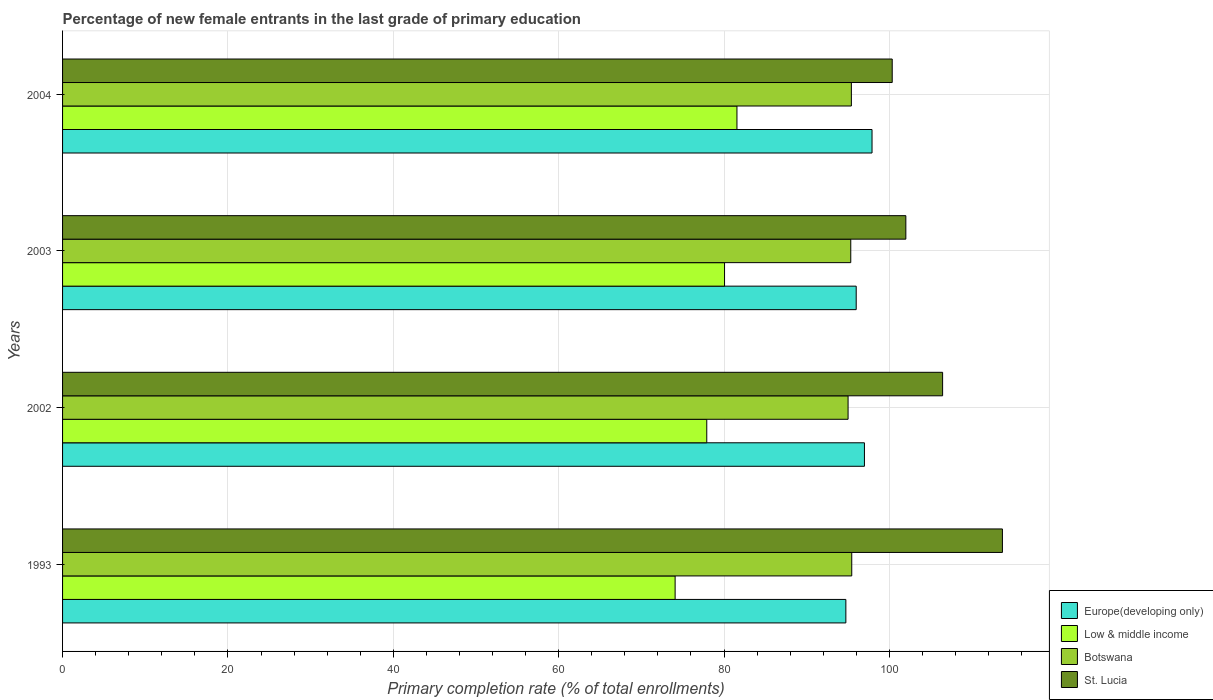Are the number of bars per tick equal to the number of legend labels?
Provide a short and direct response. Yes. Are the number of bars on each tick of the Y-axis equal?
Offer a very short reply. Yes. How many bars are there on the 4th tick from the top?
Keep it short and to the point. 4. What is the percentage of new female entrants in St. Lucia in 2004?
Your answer should be compact. 100.35. Across all years, what is the maximum percentage of new female entrants in St. Lucia?
Offer a terse response. 113.68. Across all years, what is the minimum percentage of new female entrants in St. Lucia?
Make the answer very short. 100.35. In which year was the percentage of new female entrants in Low & middle income maximum?
Provide a succinct answer. 2004. What is the total percentage of new female entrants in Europe(developing only) in the graph?
Keep it short and to the point. 385.62. What is the difference between the percentage of new female entrants in Europe(developing only) in 2002 and that in 2003?
Your response must be concise. 1. What is the difference between the percentage of new female entrants in Europe(developing only) in 1993 and the percentage of new female entrants in St. Lucia in 2002?
Provide a short and direct response. -11.7. What is the average percentage of new female entrants in Europe(developing only) per year?
Your response must be concise. 96.41. In the year 2002, what is the difference between the percentage of new female entrants in Botswana and percentage of new female entrants in St. Lucia?
Your answer should be very brief. -11.43. In how many years, is the percentage of new female entrants in St. Lucia greater than 100 %?
Your answer should be compact. 4. What is the ratio of the percentage of new female entrants in St. Lucia in 2002 to that in 2003?
Your answer should be very brief. 1.04. Is the percentage of new female entrants in Europe(developing only) in 1993 less than that in 2003?
Give a very brief answer. Yes. Is the difference between the percentage of new female entrants in Botswana in 1993 and 2002 greater than the difference between the percentage of new female entrants in St. Lucia in 1993 and 2002?
Your answer should be very brief. No. What is the difference between the highest and the second highest percentage of new female entrants in St. Lucia?
Your response must be concise. 7.24. What is the difference between the highest and the lowest percentage of new female entrants in St. Lucia?
Provide a succinct answer. 13.33. Is the sum of the percentage of new female entrants in St. Lucia in 2002 and 2003 greater than the maximum percentage of new female entrants in Low & middle income across all years?
Make the answer very short. Yes. What does the 4th bar from the top in 2002 represents?
Your answer should be very brief. Europe(developing only). Is it the case that in every year, the sum of the percentage of new female entrants in Low & middle income and percentage of new female entrants in St. Lucia is greater than the percentage of new female entrants in Botswana?
Keep it short and to the point. Yes. How many bars are there?
Offer a terse response. 16. Are all the bars in the graph horizontal?
Provide a short and direct response. Yes. Are the values on the major ticks of X-axis written in scientific E-notation?
Offer a terse response. No. Does the graph contain grids?
Ensure brevity in your answer.  Yes. How many legend labels are there?
Your response must be concise. 4. What is the title of the graph?
Provide a succinct answer. Percentage of new female entrants in the last grade of primary education. What is the label or title of the X-axis?
Offer a terse response. Primary completion rate (% of total enrollments). What is the label or title of the Y-axis?
Keep it short and to the point. Years. What is the Primary completion rate (% of total enrollments) in Europe(developing only) in 1993?
Offer a terse response. 94.74. What is the Primary completion rate (% of total enrollments) of Low & middle income in 1993?
Ensure brevity in your answer.  74.09. What is the Primary completion rate (% of total enrollments) of Botswana in 1993?
Ensure brevity in your answer.  95.45. What is the Primary completion rate (% of total enrollments) of St. Lucia in 1993?
Your response must be concise. 113.68. What is the Primary completion rate (% of total enrollments) of Europe(developing only) in 2002?
Your answer should be compact. 96.99. What is the Primary completion rate (% of total enrollments) in Low & middle income in 2002?
Make the answer very short. 77.92. What is the Primary completion rate (% of total enrollments) of Botswana in 2002?
Make the answer very short. 95.01. What is the Primary completion rate (% of total enrollments) of St. Lucia in 2002?
Offer a very short reply. 106.44. What is the Primary completion rate (% of total enrollments) in Europe(developing only) in 2003?
Ensure brevity in your answer.  95.99. What is the Primary completion rate (% of total enrollments) of Low & middle income in 2003?
Keep it short and to the point. 80.07. What is the Primary completion rate (% of total enrollments) in Botswana in 2003?
Provide a succinct answer. 95.33. What is the Primary completion rate (% of total enrollments) of St. Lucia in 2003?
Provide a short and direct response. 102. What is the Primary completion rate (% of total enrollments) of Europe(developing only) in 2004?
Give a very brief answer. 97.9. What is the Primary completion rate (% of total enrollments) in Low & middle income in 2004?
Ensure brevity in your answer.  81.57. What is the Primary completion rate (% of total enrollments) in Botswana in 2004?
Your response must be concise. 95.41. What is the Primary completion rate (% of total enrollments) of St. Lucia in 2004?
Provide a succinct answer. 100.35. Across all years, what is the maximum Primary completion rate (% of total enrollments) of Europe(developing only)?
Your answer should be very brief. 97.9. Across all years, what is the maximum Primary completion rate (% of total enrollments) in Low & middle income?
Ensure brevity in your answer.  81.57. Across all years, what is the maximum Primary completion rate (% of total enrollments) of Botswana?
Your answer should be compact. 95.45. Across all years, what is the maximum Primary completion rate (% of total enrollments) in St. Lucia?
Your answer should be compact. 113.68. Across all years, what is the minimum Primary completion rate (% of total enrollments) in Europe(developing only)?
Ensure brevity in your answer.  94.74. Across all years, what is the minimum Primary completion rate (% of total enrollments) in Low & middle income?
Provide a short and direct response. 74.09. Across all years, what is the minimum Primary completion rate (% of total enrollments) of Botswana?
Keep it short and to the point. 95.01. Across all years, what is the minimum Primary completion rate (% of total enrollments) in St. Lucia?
Your answer should be very brief. 100.35. What is the total Primary completion rate (% of total enrollments) in Europe(developing only) in the graph?
Make the answer very short. 385.62. What is the total Primary completion rate (% of total enrollments) in Low & middle income in the graph?
Provide a short and direct response. 313.64. What is the total Primary completion rate (% of total enrollments) in Botswana in the graph?
Keep it short and to the point. 381.2. What is the total Primary completion rate (% of total enrollments) in St. Lucia in the graph?
Provide a succinct answer. 422.46. What is the difference between the Primary completion rate (% of total enrollments) of Europe(developing only) in 1993 and that in 2002?
Your answer should be very brief. -2.25. What is the difference between the Primary completion rate (% of total enrollments) of Low & middle income in 1993 and that in 2002?
Ensure brevity in your answer.  -3.83. What is the difference between the Primary completion rate (% of total enrollments) in Botswana in 1993 and that in 2002?
Your response must be concise. 0.44. What is the difference between the Primary completion rate (% of total enrollments) of St. Lucia in 1993 and that in 2002?
Provide a succinct answer. 7.24. What is the difference between the Primary completion rate (% of total enrollments) in Europe(developing only) in 1993 and that in 2003?
Offer a very short reply. -1.25. What is the difference between the Primary completion rate (% of total enrollments) of Low & middle income in 1993 and that in 2003?
Provide a short and direct response. -5.98. What is the difference between the Primary completion rate (% of total enrollments) in Botswana in 1993 and that in 2003?
Provide a short and direct response. 0.12. What is the difference between the Primary completion rate (% of total enrollments) in St. Lucia in 1993 and that in 2003?
Make the answer very short. 11.68. What is the difference between the Primary completion rate (% of total enrollments) of Europe(developing only) in 1993 and that in 2004?
Your answer should be very brief. -3.17. What is the difference between the Primary completion rate (% of total enrollments) in Low & middle income in 1993 and that in 2004?
Provide a short and direct response. -7.48. What is the difference between the Primary completion rate (% of total enrollments) of Botswana in 1993 and that in 2004?
Give a very brief answer. 0.05. What is the difference between the Primary completion rate (% of total enrollments) in St. Lucia in 1993 and that in 2004?
Offer a terse response. 13.33. What is the difference between the Primary completion rate (% of total enrollments) of Europe(developing only) in 2002 and that in 2003?
Make the answer very short. 1. What is the difference between the Primary completion rate (% of total enrollments) of Low & middle income in 2002 and that in 2003?
Your response must be concise. -2.15. What is the difference between the Primary completion rate (% of total enrollments) of Botswana in 2002 and that in 2003?
Your response must be concise. -0.33. What is the difference between the Primary completion rate (% of total enrollments) in St. Lucia in 2002 and that in 2003?
Make the answer very short. 4.45. What is the difference between the Primary completion rate (% of total enrollments) in Europe(developing only) in 2002 and that in 2004?
Make the answer very short. -0.92. What is the difference between the Primary completion rate (% of total enrollments) of Low & middle income in 2002 and that in 2004?
Your response must be concise. -3.65. What is the difference between the Primary completion rate (% of total enrollments) in Botswana in 2002 and that in 2004?
Provide a succinct answer. -0.4. What is the difference between the Primary completion rate (% of total enrollments) in St. Lucia in 2002 and that in 2004?
Provide a short and direct response. 6.09. What is the difference between the Primary completion rate (% of total enrollments) of Europe(developing only) in 2003 and that in 2004?
Your response must be concise. -1.91. What is the difference between the Primary completion rate (% of total enrollments) in Low & middle income in 2003 and that in 2004?
Offer a very short reply. -1.5. What is the difference between the Primary completion rate (% of total enrollments) of Botswana in 2003 and that in 2004?
Provide a succinct answer. -0.07. What is the difference between the Primary completion rate (% of total enrollments) of St. Lucia in 2003 and that in 2004?
Provide a short and direct response. 1.65. What is the difference between the Primary completion rate (% of total enrollments) of Europe(developing only) in 1993 and the Primary completion rate (% of total enrollments) of Low & middle income in 2002?
Keep it short and to the point. 16.82. What is the difference between the Primary completion rate (% of total enrollments) of Europe(developing only) in 1993 and the Primary completion rate (% of total enrollments) of Botswana in 2002?
Your answer should be very brief. -0.27. What is the difference between the Primary completion rate (% of total enrollments) of Europe(developing only) in 1993 and the Primary completion rate (% of total enrollments) of St. Lucia in 2002?
Give a very brief answer. -11.7. What is the difference between the Primary completion rate (% of total enrollments) in Low & middle income in 1993 and the Primary completion rate (% of total enrollments) in Botswana in 2002?
Your answer should be very brief. -20.92. What is the difference between the Primary completion rate (% of total enrollments) of Low & middle income in 1993 and the Primary completion rate (% of total enrollments) of St. Lucia in 2002?
Offer a very short reply. -32.35. What is the difference between the Primary completion rate (% of total enrollments) in Botswana in 1993 and the Primary completion rate (% of total enrollments) in St. Lucia in 2002?
Give a very brief answer. -10.99. What is the difference between the Primary completion rate (% of total enrollments) in Europe(developing only) in 1993 and the Primary completion rate (% of total enrollments) in Low & middle income in 2003?
Provide a short and direct response. 14.67. What is the difference between the Primary completion rate (% of total enrollments) in Europe(developing only) in 1993 and the Primary completion rate (% of total enrollments) in Botswana in 2003?
Ensure brevity in your answer.  -0.59. What is the difference between the Primary completion rate (% of total enrollments) in Europe(developing only) in 1993 and the Primary completion rate (% of total enrollments) in St. Lucia in 2003?
Ensure brevity in your answer.  -7.26. What is the difference between the Primary completion rate (% of total enrollments) in Low & middle income in 1993 and the Primary completion rate (% of total enrollments) in Botswana in 2003?
Make the answer very short. -21.24. What is the difference between the Primary completion rate (% of total enrollments) in Low & middle income in 1993 and the Primary completion rate (% of total enrollments) in St. Lucia in 2003?
Provide a short and direct response. -27.91. What is the difference between the Primary completion rate (% of total enrollments) of Botswana in 1993 and the Primary completion rate (% of total enrollments) of St. Lucia in 2003?
Your answer should be compact. -6.54. What is the difference between the Primary completion rate (% of total enrollments) of Europe(developing only) in 1993 and the Primary completion rate (% of total enrollments) of Low & middle income in 2004?
Offer a very short reply. 13.17. What is the difference between the Primary completion rate (% of total enrollments) in Europe(developing only) in 1993 and the Primary completion rate (% of total enrollments) in Botswana in 2004?
Give a very brief answer. -0.67. What is the difference between the Primary completion rate (% of total enrollments) of Europe(developing only) in 1993 and the Primary completion rate (% of total enrollments) of St. Lucia in 2004?
Offer a very short reply. -5.61. What is the difference between the Primary completion rate (% of total enrollments) in Low & middle income in 1993 and the Primary completion rate (% of total enrollments) in Botswana in 2004?
Provide a short and direct response. -21.32. What is the difference between the Primary completion rate (% of total enrollments) of Low & middle income in 1993 and the Primary completion rate (% of total enrollments) of St. Lucia in 2004?
Offer a terse response. -26.26. What is the difference between the Primary completion rate (% of total enrollments) in Botswana in 1993 and the Primary completion rate (% of total enrollments) in St. Lucia in 2004?
Provide a short and direct response. -4.89. What is the difference between the Primary completion rate (% of total enrollments) of Europe(developing only) in 2002 and the Primary completion rate (% of total enrollments) of Low & middle income in 2003?
Offer a very short reply. 16.92. What is the difference between the Primary completion rate (% of total enrollments) in Europe(developing only) in 2002 and the Primary completion rate (% of total enrollments) in Botswana in 2003?
Your answer should be very brief. 1.65. What is the difference between the Primary completion rate (% of total enrollments) in Europe(developing only) in 2002 and the Primary completion rate (% of total enrollments) in St. Lucia in 2003?
Provide a succinct answer. -5.01. What is the difference between the Primary completion rate (% of total enrollments) of Low & middle income in 2002 and the Primary completion rate (% of total enrollments) of Botswana in 2003?
Provide a succinct answer. -17.42. What is the difference between the Primary completion rate (% of total enrollments) in Low & middle income in 2002 and the Primary completion rate (% of total enrollments) in St. Lucia in 2003?
Provide a short and direct response. -24.08. What is the difference between the Primary completion rate (% of total enrollments) in Botswana in 2002 and the Primary completion rate (% of total enrollments) in St. Lucia in 2003?
Your answer should be very brief. -6.99. What is the difference between the Primary completion rate (% of total enrollments) in Europe(developing only) in 2002 and the Primary completion rate (% of total enrollments) in Low & middle income in 2004?
Make the answer very short. 15.42. What is the difference between the Primary completion rate (% of total enrollments) of Europe(developing only) in 2002 and the Primary completion rate (% of total enrollments) of Botswana in 2004?
Offer a very short reply. 1.58. What is the difference between the Primary completion rate (% of total enrollments) in Europe(developing only) in 2002 and the Primary completion rate (% of total enrollments) in St. Lucia in 2004?
Offer a very short reply. -3.36. What is the difference between the Primary completion rate (% of total enrollments) in Low & middle income in 2002 and the Primary completion rate (% of total enrollments) in Botswana in 2004?
Give a very brief answer. -17.49. What is the difference between the Primary completion rate (% of total enrollments) in Low & middle income in 2002 and the Primary completion rate (% of total enrollments) in St. Lucia in 2004?
Your answer should be very brief. -22.43. What is the difference between the Primary completion rate (% of total enrollments) in Botswana in 2002 and the Primary completion rate (% of total enrollments) in St. Lucia in 2004?
Your answer should be very brief. -5.34. What is the difference between the Primary completion rate (% of total enrollments) of Europe(developing only) in 2003 and the Primary completion rate (% of total enrollments) of Low & middle income in 2004?
Keep it short and to the point. 14.42. What is the difference between the Primary completion rate (% of total enrollments) of Europe(developing only) in 2003 and the Primary completion rate (% of total enrollments) of Botswana in 2004?
Keep it short and to the point. 0.58. What is the difference between the Primary completion rate (% of total enrollments) in Europe(developing only) in 2003 and the Primary completion rate (% of total enrollments) in St. Lucia in 2004?
Make the answer very short. -4.36. What is the difference between the Primary completion rate (% of total enrollments) of Low & middle income in 2003 and the Primary completion rate (% of total enrollments) of Botswana in 2004?
Ensure brevity in your answer.  -15.34. What is the difference between the Primary completion rate (% of total enrollments) of Low & middle income in 2003 and the Primary completion rate (% of total enrollments) of St. Lucia in 2004?
Your response must be concise. -20.28. What is the difference between the Primary completion rate (% of total enrollments) in Botswana in 2003 and the Primary completion rate (% of total enrollments) in St. Lucia in 2004?
Your answer should be very brief. -5.01. What is the average Primary completion rate (% of total enrollments) in Europe(developing only) per year?
Make the answer very short. 96.41. What is the average Primary completion rate (% of total enrollments) of Low & middle income per year?
Offer a terse response. 78.41. What is the average Primary completion rate (% of total enrollments) in Botswana per year?
Offer a terse response. 95.3. What is the average Primary completion rate (% of total enrollments) in St. Lucia per year?
Provide a succinct answer. 105.61. In the year 1993, what is the difference between the Primary completion rate (% of total enrollments) in Europe(developing only) and Primary completion rate (% of total enrollments) in Low & middle income?
Offer a very short reply. 20.65. In the year 1993, what is the difference between the Primary completion rate (% of total enrollments) in Europe(developing only) and Primary completion rate (% of total enrollments) in Botswana?
Your answer should be very brief. -0.71. In the year 1993, what is the difference between the Primary completion rate (% of total enrollments) in Europe(developing only) and Primary completion rate (% of total enrollments) in St. Lucia?
Offer a very short reply. -18.94. In the year 1993, what is the difference between the Primary completion rate (% of total enrollments) in Low & middle income and Primary completion rate (% of total enrollments) in Botswana?
Offer a terse response. -21.36. In the year 1993, what is the difference between the Primary completion rate (% of total enrollments) in Low & middle income and Primary completion rate (% of total enrollments) in St. Lucia?
Make the answer very short. -39.59. In the year 1993, what is the difference between the Primary completion rate (% of total enrollments) in Botswana and Primary completion rate (% of total enrollments) in St. Lucia?
Provide a succinct answer. -18.22. In the year 2002, what is the difference between the Primary completion rate (% of total enrollments) in Europe(developing only) and Primary completion rate (% of total enrollments) in Low & middle income?
Your answer should be very brief. 19.07. In the year 2002, what is the difference between the Primary completion rate (% of total enrollments) of Europe(developing only) and Primary completion rate (% of total enrollments) of Botswana?
Give a very brief answer. 1.98. In the year 2002, what is the difference between the Primary completion rate (% of total enrollments) in Europe(developing only) and Primary completion rate (% of total enrollments) in St. Lucia?
Your answer should be compact. -9.45. In the year 2002, what is the difference between the Primary completion rate (% of total enrollments) of Low & middle income and Primary completion rate (% of total enrollments) of Botswana?
Your answer should be very brief. -17.09. In the year 2002, what is the difference between the Primary completion rate (% of total enrollments) of Low & middle income and Primary completion rate (% of total enrollments) of St. Lucia?
Offer a very short reply. -28.52. In the year 2002, what is the difference between the Primary completion rate (% of total enrollments) in Botswana and Primary completion rate (% of total enrollments) in St. Lucia?
Give a very brief answer. -11.43. In the year 2003, what is the difference between the Primary completion rate (% of total enrollments) of Europe(developing only) and Primary completion rate (% of total enrollments) of Low & middle income?
Offer a very short reply. 15.92. In the year 2003, what is the difference between the Primary completion rate (% of total enrollments) of Europe(developing only) and Primary completion rate (% of total enrollments) of Botswana?
Your answer should be compact. 0.66. In the year 2003, what is the difference between the Primary completion rate (% of total enrollments) of Europe(developing only) and Primary completion rate (% of total enrollments) of St. Lucia?
Provide a succinct answer. -6. In the year 2003, what is the difference between the Primary completion rate (% of total enrollments) in Low & middle income and Primary completion rate (% of total enrollments) in Botswana?
Offer a terse response. -15.27. In the year 2003, what is the difference between the Primary completion rate (% of total enrollments) in Low & middle income and Primary completion rate (% of total enrollments) in St. Lucia?
Keep it short and to the point. -21.93. In the year 2003, what is the difference between the Primary completion rate (% of total enrollments) in Botswana and Primary completion rate (% of total enrollments) in St. Lucia?
Your answer should be very brief. -6.66. In the year 2004, what is the difference between the Primary completion rate (% of total enrollments) of Europe(developing only) and Primary completion rate (% of total enrollments) of Low & middle income?
Ensure brevity in your answer.  16.34. In the year 2004, what is the difference between the Primary completion rate (% of total enrollments) of Europe(developing only) and Primary completion rate (% of total enrollments) of Botswana?
Give a very brief answer. 2.5. In the year 2004, what is the difference between the Primary completion rate (% of total enrollments) in Europe(developing only) and Primary completion rate (% of total enrollments) in St. Lucia?
Offer a very short reply. -2.44. In the year 2004, what is the difference between the Primary completion rate (% of total enrollments) in Low & middle income and Primary completion rate (% of total enrollments) in Botswana?
Your answer should be compact. -13.84. In the year 2004, what is the difference between the Primary completion rate (% of total enrollments) in Low & middle income and Primary completion rate (% of total enrollments) in St. Lucia?
Your answer should be compact. -18.78. In the year 2004, what is the difference between the Primary completion rate (% of total enrollments) in Botswana and Primary completion rate (% of total enrollments) in St. Lucia?
Provide a short and direct response. -4.94. What is the ratio of the Primary completion rate (% of total enrollments) of Europe(developing only) in 1993 to that in 2002?
Your answer should be very brief. 0.98. What is the ratio of the Primary completion rate (% of total enrollments) in Low & middle income in 1993 to that in 2002?
Your answer should be compact. 0.95. What is the ratio of the Primary completion rate (% of total enrollments) of Botswana in 1993 to that in 2002?
Your answer should be compact. 1. What is the ratio of the Primary completion rate (% of total enrollments) in St. Lucia in 1993 to that in 2002?
Provide a short and direct response. 1.07. What is the ratio of the Primary completion rate (% of total enrollments) in Low & middle income in 1993 to that in 2003?
Offer a very short reply. 0.93. What is the ratio of the Primary completion rate (% of total enrollments) of St. Lucia in 1993 to that in 2003?
Ensure brevity in your answer.  1.11. What is the ratio of the Primary completion rate (% of total enrollments) in Low & middle income in 1993 to that in 2004?
Give a very brief answer. 0.91. What is the ratio of the Primary completion rate (% of total enrollments) of St. Lucia in 1993 to that in 2004?
Keep it short and to the point. 1.13. What is the ratio of the Primary completion rate (% of total enrollments) of Europe(developing only) in 2002 to that in 2003?
Offer a very short reply. 1.01. What is the ratio of the Primary completion rate (% of total enrollments) in Low & middle income in 2002 to that in 2003?
Offer a very short reply. 0.97. What is the ratio of the Primary completion rate (% of total enrollments) of St. Lucia in 2002 to that in 2003?
Make the answer very short. 1.04. What is the ratio of the Primary completion rate (% of total enrollments) in Europe(developing only) in 2002 to that in 2004?
Offer a very short reply. 0.99. What is the ratio of the Primary completion rate (% of total enrollments) of Low & middle income in 2002 to that in 2004?
Make the answer very short. 0.96. What is the ratio of the Primary completion rate (% of total enrollments) of Botswana in 2002 to that in 2004?
Provide a succinct answer. 1. What is the ratio of the Primary completion rate (% of total enrollments) of St. Lucia in 2002 to that in 2004?
Your response must be concise. 1.06. What is the ratio of the Primary completion rate (% of total enrollments) of Europe(developing only) in 2003 to that in 2004?
Your answer should be very brief. 0.98. What is the ratio of the Primary completion rate (% of total enrollments) in Low & middle income in 2003 to that in 2004?
Your answer should be compact. 0.98. What is the ratio of the Primary completion rate (% of total enrollments) in St. Lucia in 2003 to that in 2004?
Your answer should be very brief. 1.02. What is the difference between the highest and the second highest Primary completion rate (% of total enrollments) in Europe(developing only)?
Offer a very short reply. 0.92. What is the difference between the highest and the second highest Primary completion rate (% of total enrollments) in Low & middle income?
Give a very brief answer. 1.5. What is the difference between the highest and the second highest Primary completion rate (% of total enrollments) in Botswana?
Your response must be concise. 0.05. What is the difference between the highest and the second highest Primary completion rate (% of total enrollments) of St. Lucia?
Your answer should be compact. 7.24. What is the difference between the highest and the lowest Primary completion rate (% of total enrollments) in Europe(developing only)?
Provide a short and direct response. 3.17. What is the difference between the highest and the lowest Primary completion rate (% of total enrollments) in Low & middle income?
Your answer should be compact. 7.48. What is the difference between the highest and the lowest Primary completion rate (% of total enrollments) in Botswana?
Provide a succinct answer. 0.44. What is the difference between the highest and the lowest Primary completion rate (% of total enrollments) of St. Lucia?
Keep it short and to the point. 13.33. 